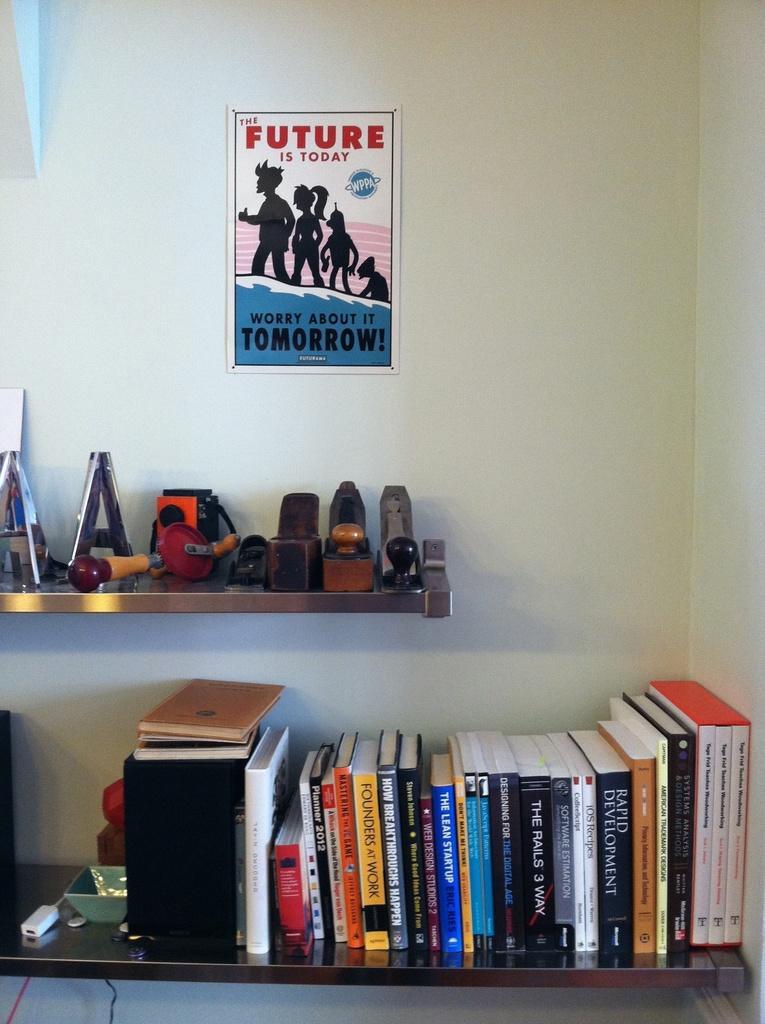How would you summarize this image in a sentence or two? In this image we can see the books placed on the rack and we can also see some objects on the rack. There is a poster attached to the plain wall. 